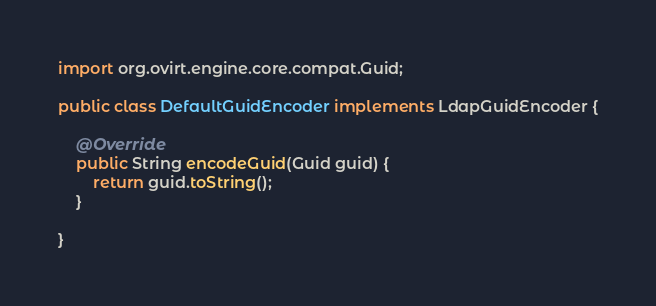Convert code to text. <code><loc_0><loc_0><loc_500><loc_500><_Java_>
import org.ovirt.engine.core.compat.Guid;

public class DefaultGuidEncoder implements LdapGuidEncoder {

    @Override
    public String encodeGuid(Guid guid) {
        return guid.toString();
    }

}
</code> 